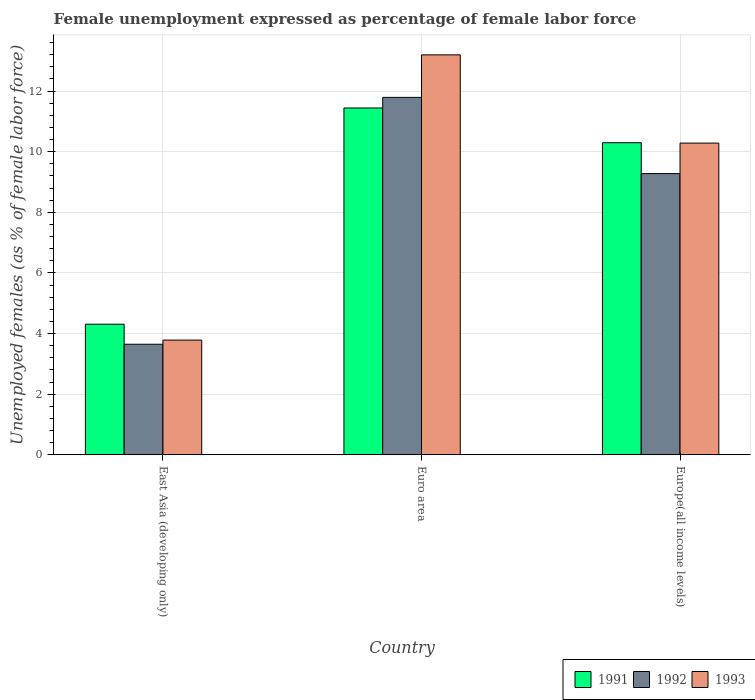How many different coloured bars are there?
Provide a succinct answer. 3. How many groups of bars are there?
Your answer should be compact. 3. Are the number of bars on each tick of the X-axis equal?
Your answer should be very brief. Yes. How many bars are there on the 3rd tick from the right?
Keep it short and to the point. 3. What is the label of the 3rd group of bars from the left?
Your response must be concise. Europe(all income levels). What is the unemployment in females in in 1993 in Europe(all income levels)?
Offer a terse response. 10.28. Across all countries, what is the maximum unemployment in females in in 1992?
Provide a short and direct response. 11.79. Across all countries, what is the minimum unemployment in females in in 1992?
Make the answer very short. 3.65. In which country was the unemployment in females in in 1993 minimum?
Offer a very short reply. East Asia (developing only). What is the total unemployment in females in in 1992 in the graph?
Your answer should be compact. 24.72. What is the difference between the unemployment in females in in 1993 in East Asia (developing only) and that in Europe(all income levels)?
Your answer should be very brief. -6.5. What is the difference between the unemployment in females in in 1992 in Euro area and the unemployment in females in in 1993 in East Asia (developing only)?
Keep it short and to the point. 8.01. What is the average unemployment in females in in 1991 per country?
Your answer should be very brief. 8.68. What is the difference between the unemployment in females in of/in 1991 and unemployment in females in of/in 1992 in East Asia (developing only)?
Offer a terse response. 0.66. In how many countries, is the unemployment in females in in 1992 greater than 5.6 %?
Your answer should be compact. 2. What is the ratio of the unemployment in females in in 1992 in Euro area to that in Europe(all income levels)?
Make the answer very short. 1.27. What is the difference between the highest and the second highest unemployment in females in in 1993?
Provide a succinct answer. 6.5. What is the difference between the highest and the lowest unemployment in females in in 1991?
Make the answer very short. 7.13. What does the 1st bar from the left in Euro area represents?
Give a very brief answer. 1991. How many bars are there?
Your response must be concise. 9. Are the values on the major ticks of Y-axis written in scientific E-notation?
Offer a terse response. No. Does the graph contain grids?
Offer a very short reply. Yes. How many legend labels are there?
Provide a succinct answer. 3. How are the legend labels stacked?
Your answer should be very brief. Horizontal. What is the title of the graph?
Keep it short and to the point. Female unemployment expressed as percentage of female labor force. Does "1991" appear as one of the legend labels in the graph?
Provide a short and direct response. Yes. What is the label or title of the Y-axis?
Your answer should be compact. Unemployed females (as % of female labor force). What is the Unemployed females (as % of female labor force) of 1991 in East Asia (developing only)?
Your answer should be compact. 4.31. What is the Unemployed females (as % of female labor force) of 1992 in East Asia (developing only)?
Your answer should be very brief. 3.65. What is the Unemployed females (as % of female labor force) in 1993 in East Asia (developing only)?
Your answer should be compact. 3.78. What is the Unemployed females (as % of female labor force) of 1991 in Euro area?
Your answer should be very brief. 11.44. What is the Unemployed females (as % of female labor force) in 1992 in Euro area?
Provide a succinct answer. 11.79. What is the Unemployed females (as % of female labor force) of 1993 in Euro area?
Your answer should be compact. 13.2. What is the Unemployed females (as % of female labor force) in 1991 in Europe(all income levels)?
Your response must be concise. 10.3. What is the Unemployed females (as % of female labor force) of 1992 in Europe(all income levels)?
Your answer should be very brief. 9.28. What is the Unemployed females (as % of female labor force) of 1993 in Europe(all income levels)?
Offer a very short reply. 10.28. Across all countries, what is the maximum Unemployed females (as % of female labor force) in 1991?
Offer a terse response. 11.44. Across all countries, what is the maximum Unemployed females (as % of female labor force) of 1992?
Your answer should be very brief. 11.79. Across all countries, what is the maximum Unemployed females (as % of female labor force) in 1993?
Offer a very short reply. 13.2. Across all countries, what is the minimum Unemployed females (as % of female labor force) in 1991?
Ensure brevity in your answer.  4.31. Across all countries, what is the minimum Unemployed females (as % of female labor force) of 1992?
Offer a terse response. 3.65. Across all countries, what is the minimum Unemployed females (as % of female labor force) in 1993?
Provide a short and direct response. 3.78. What is the total Unemployed females (as % of female labor force) of 1991 in the graph?
Provide a succinct answer. 26.05. What is the total Unemployed females (as % of female labor force) in 1992 in the graph?
Your answer should be compact. 24.72. What is the total Unemployed females (as % of female labor force) of 1993 in the graph?
Keep it short and to the point. 27.26. What is the difference between the Unemployed females (as % of female labor force) in 1991 in East Asia (developing only) and that in Euro area?
Provide a succinct answer. -7.13. What is the difference between the Unemployed females (as % of female labor force) of 1992 in East Asia (developing only) and that in Euro area?
Provide a succinct answer. -8.14. What is the difference between the Unemployed females (as % of female labor force) of 1993 in East Asia (developing only) and that in Euro area?
Keep it short and to the point. -9.41. What is the difference between the Unemployed females (as % of female labor force) in 1991 in East Asia (developing only) and that in Europe(all income levels)?
Your response must be concise. -5.99. What is the difference between the Unemployed females (as % of female labor force) in 1992 in East Asia (developing only) and that in Europe(all income levels)?
Offer a very short reply. -5.63. What is the difference between the Unemployed females (as % of female labor force) in 1993 in East Asia (developing only) and that in Europe(all income levels)?
Offer a very short reply. -6.5. What is the difference between the Unemployed females (as % of female labor force) in 1991 in Euro area and that in Europe(all income levels)?
Keep it short and to the point. 1.15. What is the difference between the Unemployed females (as % of female labor force) in 1992 in Euro area and that in Europe(all income levels)?
Your answer should be compact. 2.51. What is the difference between the Unemployed females (as % of female labor force) in 1993 in Euro area and that in Europe(all income levels)?
Give a very brief answer. 2.91. What is the difference between the Unemployed females (as % of female labor force) in 1991 in East Asia (developing only) and the Unemployed females (as % of female labor force) in 1992 in Euro area?
Your response must be concise. -7.48. What is the difference between the Unemployed females (as % of female labor force) of 1991 in East Asia (developing only) and the Unemployed females (as % of female labor force) of 1993 in Euro area?
Provide a short and direct response. -8.89. What is the difference between the Unemployed females (as % of female labor force) in 1992 in East Asia (developing only) and the Unemployed females (as % of female labor force) in 1993 in Euro area?
Your response must be concise. -9.55. What is the difference between the Unemployed females (as % of female labor force) of 1991 in East Asia (developing only) and the Unemployed females (as % of female labor force) of 1992 in Europe(all income levels)?
Your response must be concise. -4.97. What is the difference between the Unemployed females (as % of female labor force) in 1991 in East Asia (developing only) and the Unemployed females (as % of female labor force) in 1993 in Europe(all income levels)?
Your response must be concise. -5.98. What is the difference between the Unemployed females (as % of female labor force) in 1992 in East Asia (developing only) and the Unemployed females (as % of female labor force) in 1993 in Europe(all income levels)?
Provide a succinct answer. -6.64. What is the difference between the Unemployed females (as % of female labor force) in 1991 in Euro area and the Unemployed females (as % of female labor force) in 1992 in Europe(all income levels)?
Provide a short and direct response. 2.17. What is the difference between the Unemployed females (as % of female labor force) in 1991 in Euro area and the Unemployed females (as % of female labor force) in 1993 in Europe(all income levels)?
Your answer should be compact. 1.16. What is the difference between the Unemployed females (as % of female labor force) of 1992 in Euro area and the Unemployed females (as % of female labor force) of 1993 in Europe(all income levels)?
Give a very brief answer. 1.51. What is the average Unemployed females (as % of female labor force) in 1991 per country?
Keep it short and to the point. 8.68. What is the average Unemployed females (as % of female labor force) in 1992 per country?
Offer a terse response. 8.24. What is the average Unemployed females (as % of female labor force) of 1993 per country?
Your answer should be compact. 9.09. What is the difference between the Unemployed females (as % of female labor force) of 1991 and Unemployed females (as % of female labor force) of 1992 in East Asia (developing only)?
Your response must be concise. 0.66. What is the difference between the Unemployed females (as % of female labor force) in 1991 and Unemployed females (as % of female labor force) in 1993 in East Asia (developing only)?
Offer a terse response. 0.52. What is the difference between the Unemployed females (as % of female labor force) of 1992 and Unemployed females (as % of female labor force) of 1993 in East Asia (developing only)?
Ensure brevity in your answer.  -0.14. What is the difference between the Unemployed females (as % of female labor force) in 1991 and Unemployed females (as % of female labor force) in 1992 in Euro area?
Offer a terse response. -0.35. What is the difference between the Unemployed females (as % of female labor force) in 1991 and Unemployed females (as % of female labor force) in 1993 in Euro area?
Give a very brief answer. -1.75. What is the difference between the Unemployed females (as % of female labor force) in 1992 and Unemployed females (as % of female labor force) in 1993 in Euro area?
Provide a succinct answer. -1.4. What is the difference between the Unemployed females (as % of female labor force) of 1991 and Unemployed females (as % of female labor force) of 1992 in Europe(all income levels)?
Your answer should be compact. 1.02. What is the difference between the Unemployed females (as % of female labor force) in 1991 and Unemployed females (as % of female labor force) in 1993 in Europe(all income levels)?
Your answer should be compact. 0.01. What is the difference between the Unemployed females (as % of female labor force) in 1992 and Unemployed females (as % of female labor force) in 1993 in Europe(all income levels)?
Offer a very short reply. -1.01. What is the ratio of the Unemployed females (as % of female labor force) in 1991 in East Asia (developing only) to that in Euro area?
Give a very brief answer. 0.38. What is the ratio of the Unemployed females (as % of female labor force) of 1992 in East Asia (developing only) to that in Euro area?
Ensure brevity in your answer.  0.31. What is the ratio of the Unemployed females (as % of female labor force) of 1993 in East Asia (developing only) to that in Euro area?
Your answer should be compact. 0.29. What is the ratio of the Unemployed females (as % of female labor force) of 1991 in East Asia (developing only) to that in Europe(all income levels)?
Offer a terse response. 0.42. What is the ratio of the Unemployed females (as % of female labor force) in 1992 in East Asia (developing only) to that in Europe(all income levels)?
Offer a terse response. 0.39. What is the ratio of the Unemployed females (as % of female labor force) of 1993 in East Asia (developing only) to that in Europe(all income levels)?
Ensure brevity in your answer.  0.37. What is the ratio of the Unemployed females (as % of female labor force) of 1991 in Euro area to that in Europe(all income levels)?
Keep it short and to the point. 1.11. What is the ratio of the Unemployed females (as % of female labor force) in 1992 in Euro area to that in Europe(all income levels)?
Give a very brief answer. 1.27. What is the ratio of the Unemployed females (as % of female labor force) of 1993 in Euro area to that in Europe(all income levels)?
Your answer should be very brief. 1.28. What is the difference between the highest and the second highest Unemployed females (as % of female labor force) of 1991?
Offer a terse response. 1.15. What is the difference between the highest and the second highest Unemployed females (as % of female labor force) of 1992?
Provide a succinct answer. 2.51. What is the difference between the highest and the second highest Unemployed females (as % of female labor force) of 1993?
Your response must be concise. 2.91. What is the difference between the highest and the lowest Unemployed females (as % of female labor force) of 1991?
Offer a terse response. 7.13. What is the difference between the highest and the lowest Unemployed females (as % of female labor force) in 1992?
Ensure brevity in your answer.  8.14. What is the difference between the highest and the lowest Unemployed females (as % of female labor force) of 1993?
Your response must be concise. 9.41. 